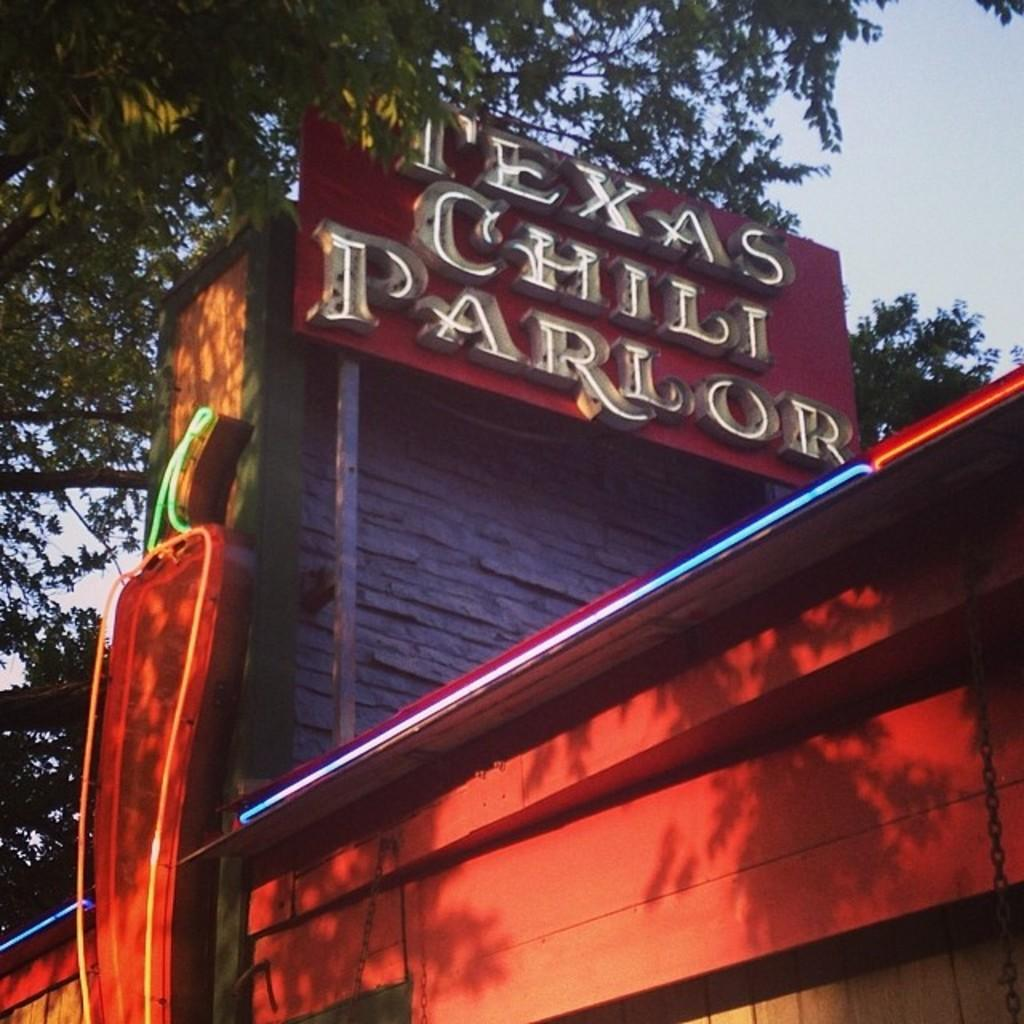What type of structure is present in the image? There is a building in the image. Is there any signage or identification for the building? Yes, there is a name board in the image. What type of natural elements can be seen in the image? There are trees in the image. What is visible in the background of the image? The sky is visible in the image. How much debt is the building in the image currently facing? There is no information about the building's debt in the image. 